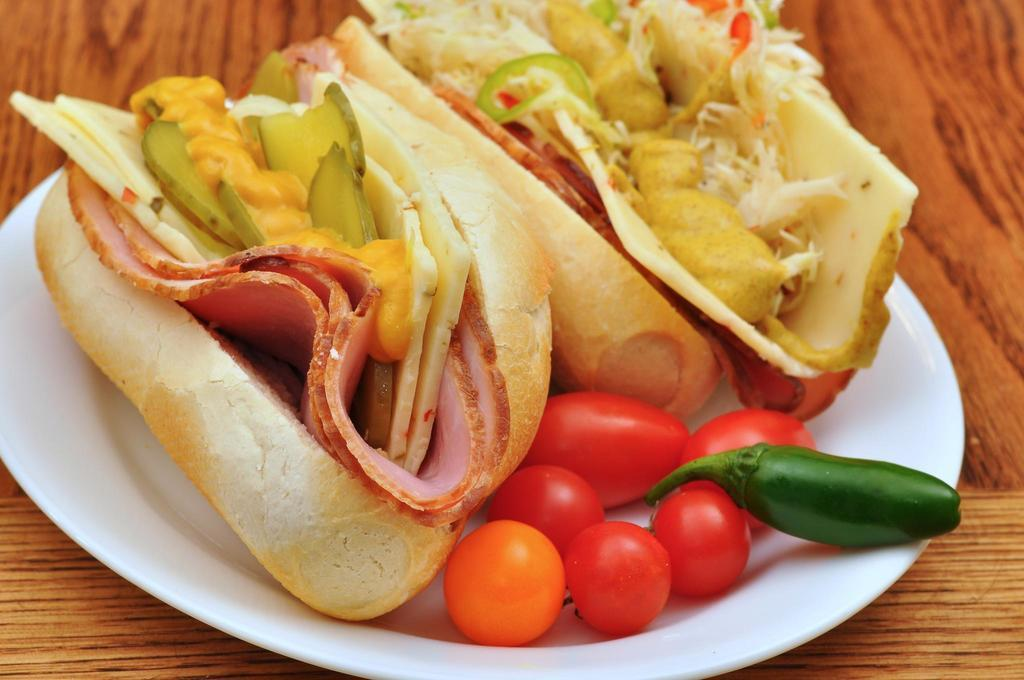What is on the serving plate in the image? The serving plate contains food. Where is the serving plate located in the image? The serving plate is placed on a table. How many tickets are on the serving plate in the image? There are no tickets present on the serving plate in the image; it contains food. 